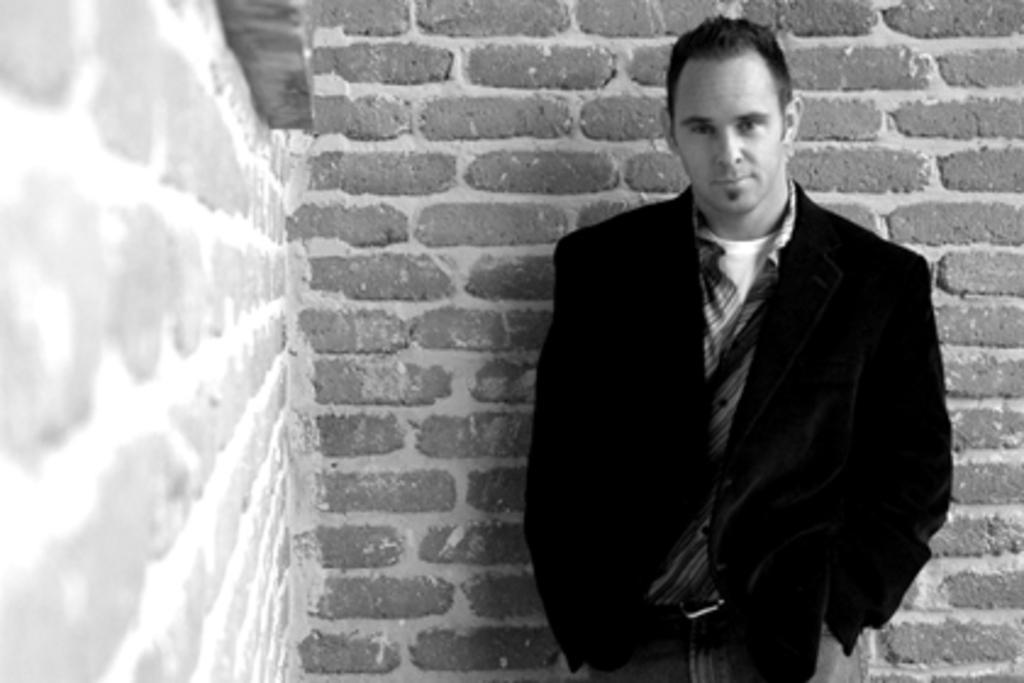How would you summarize this image in a sentence or two? In this picture I can see a man standing and I can see a brick wall. 